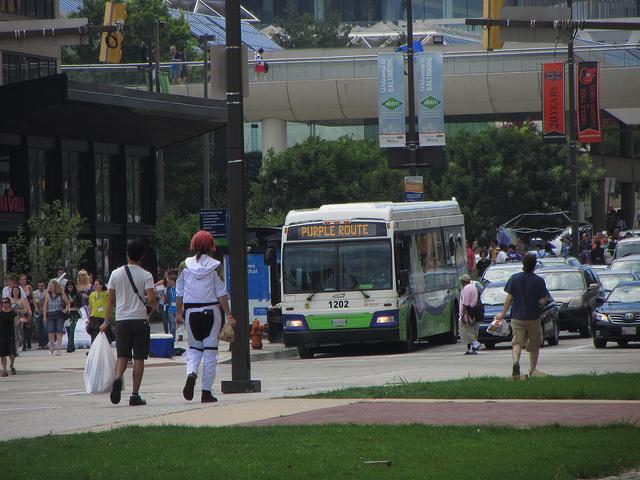Is it sunny?:?
Short answer required. Yes. How is the weather?
Give a very brief answer. Clear. What does the lights on the bus say?
Write a very short answer. Purple route. Is there anyone standing on the sidewalk?
Answer briefly. Yes. What is the number on the bus?
Write a very short answer. 1202. Are there any palm trees?
Short answer required. No. 